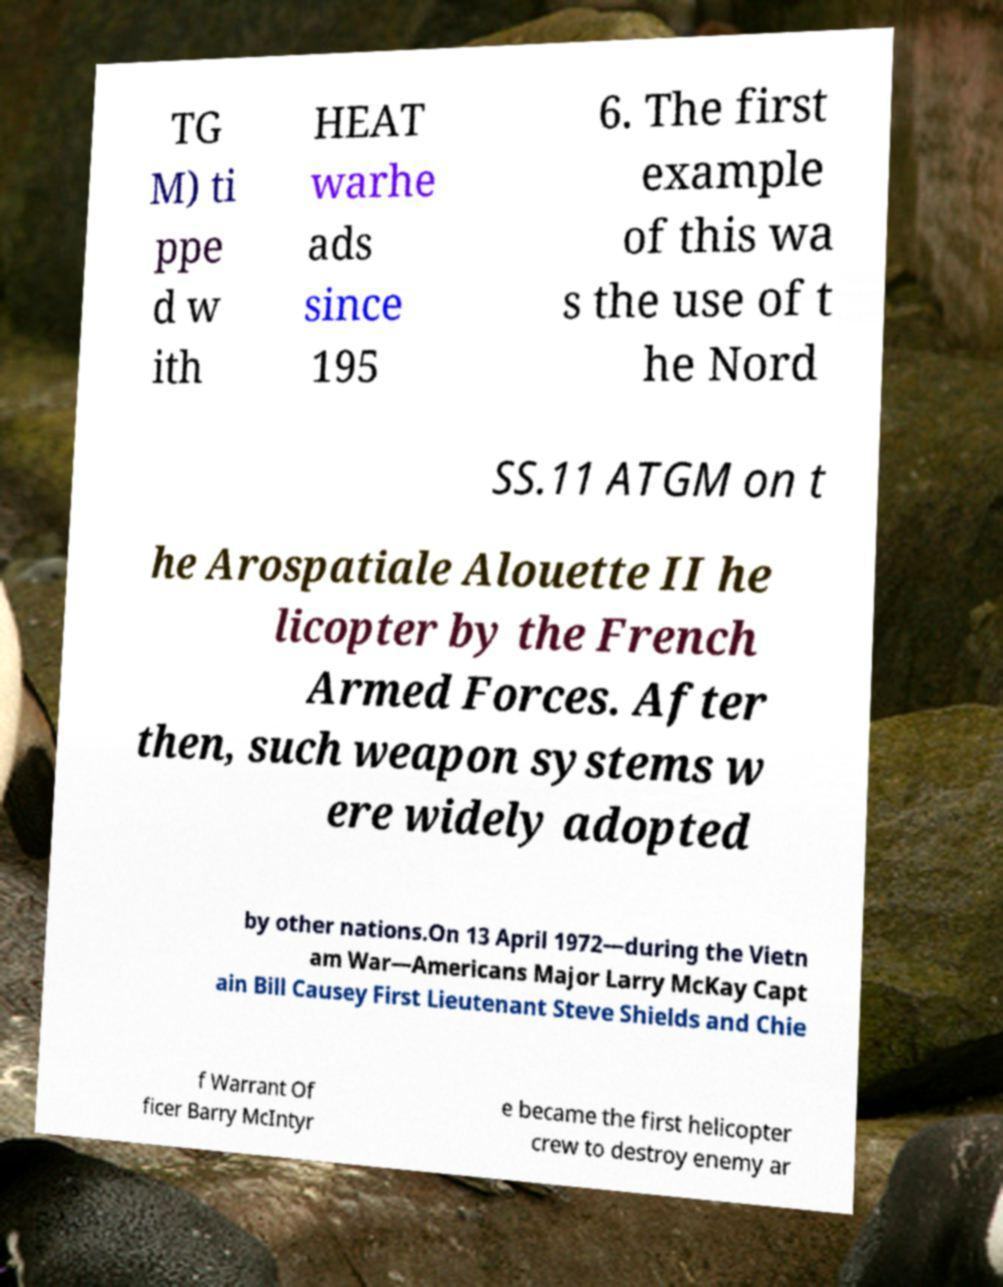What messages or text are displayed in this image? I need them in a readable, typed format. TG M) ti ppe d w ith HEAT warhe ads since 195 6. The first example of this wa s the use of t he Nord SS.11 ATGM on t he Arospatiale Alouette II he licopter by the French Armed Forces. After then, such weapon systems w ere widely adopted by other nations.On 13 April 1972—during the Vietn am War—Americans Major Larry McKay Capt ain Bill Causey First Lieutenant Steve Shields and Chie f Warrant Of ficer Barry McIntyr e became the first helicopter crew to destroy enemy ar 